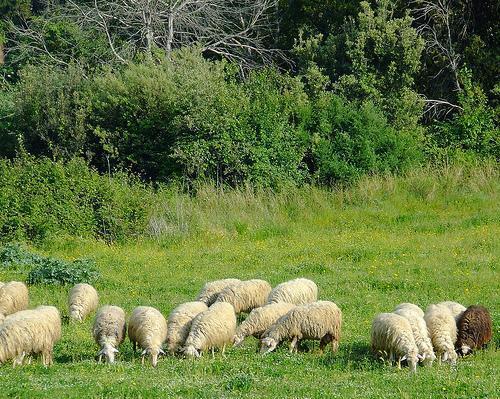How many people are there?
Give a very brief answer. 0. 